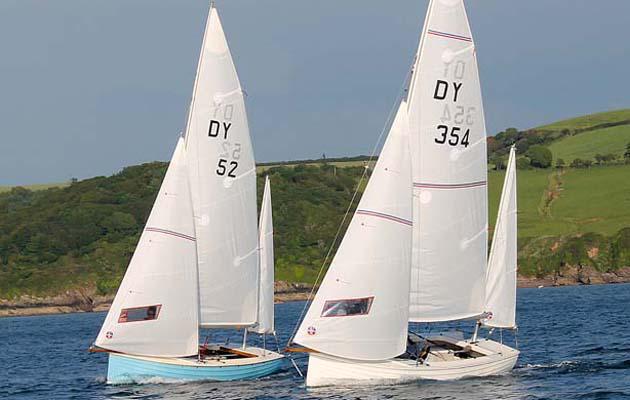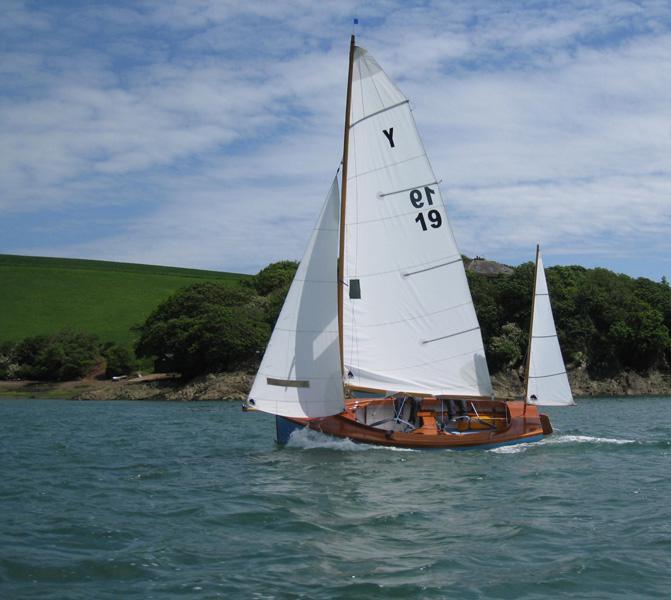The first image is the image on the left, the second image is the image on the right. Examine the images to the left and right. Is the description "A total of one sailboat with brown sails is pictured." accurate? Answer yes or no. No. The first image is the image on the left, the second image is the image on the right. Examine the images to the left and right. Is the description "All boats have sails in the same colour." accurate? Answer yes or no. Yes. 